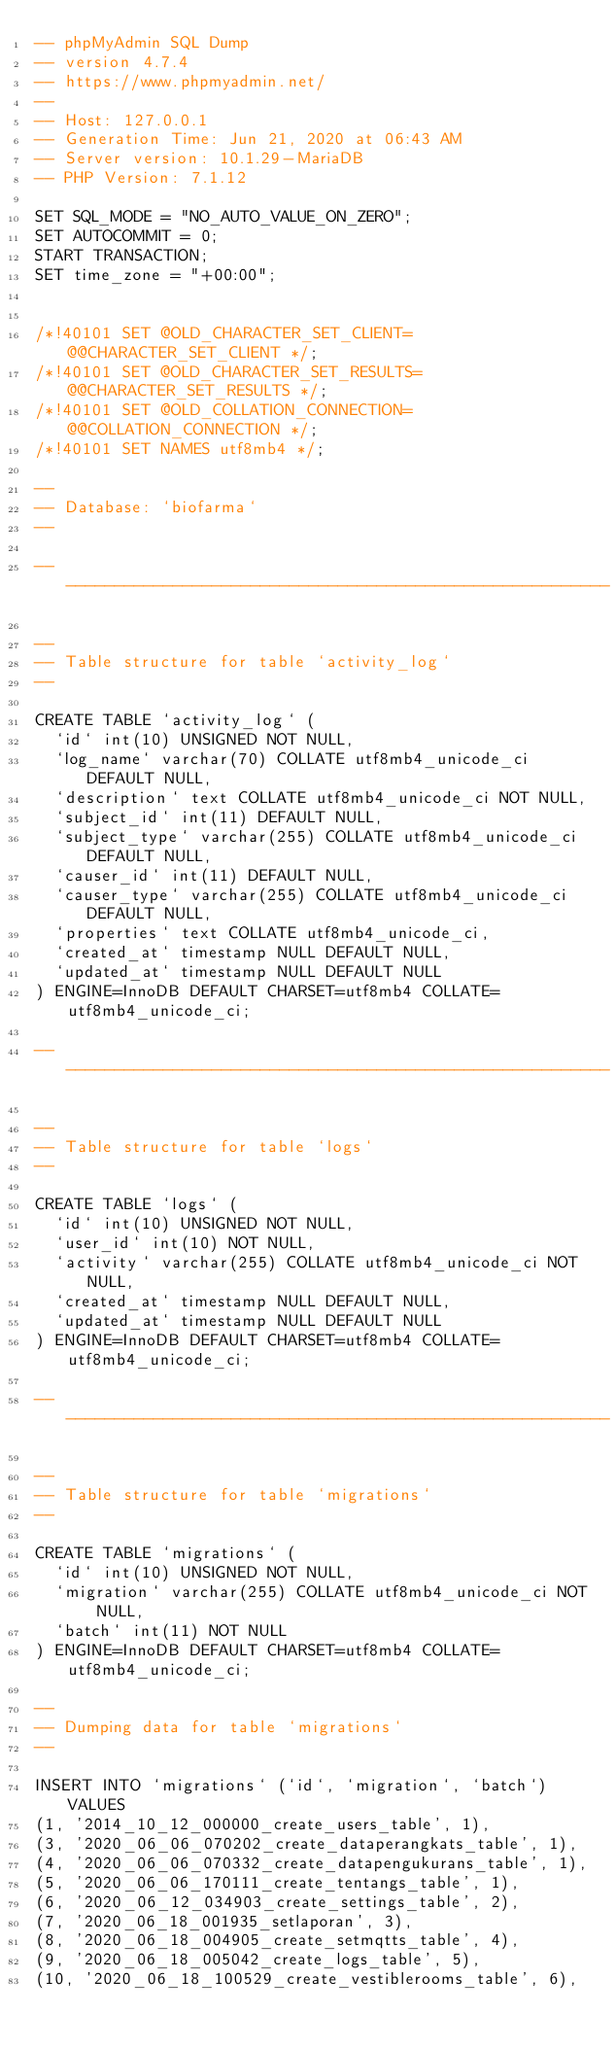<code> <loc_0><loc_0><loc_500><loc_500><_SQL_>-- phpMyAdmin SQL Dump
-- version 4.7.4
-- https://www.phpmyadmin.net/
--
-- Host: 127.0.0.1
-- Generation Time: Jun 21, 2020 at 06:43 AM
-- Server version: 10.1.29-MariaDB
-- PHP Version: 7.1.12

SET SQL_MODE = "NO_AUTO_VALUE_ON_ZERO";
SET AUTOCOMMIT = 0;
START TRANSACTION;
SET time_zone = "+00:00";


/*!40101 SET @OLD_CHARACTER_SET_CLIENT=@@CHARACTER_SET_CLIENT */;
/*!40101 SET @OLD_CHARACTER_SET_RESULTS=@@CHARACTER_SET_RESULTS */;
/*!40101 SET @OLD_COLLATION_CONNECTION=@@COLLATION_CONNECTION */;
/*!40101 SET NAMES utf8mb4 */;

--
-- Database: `biofarma`
--

-- --------------------------------------------------------

--
-- Table structure for table `activity_log`
--

CREATE TABLE `activity_log` (
  `id` int(10) UNSIGNED NOT NULL,
  `log_name` varchar(70) COLLATE utf8mb4_unicode_ci DEFAULT NULL,
  `description` text COLLATE utf8mb4_unicode_ci NOT NULL,
  `subject_id` int(11) DEFAULT NULL,
  `subject_type` varchar(255) COLLATE utf8mb4_unicode_ci DEFAULT NULL,
  `causer_id` int(11) DEFAULT NULL,
  `causer_type` varchar(255) COLLATE utf8mb4_unicode_ci DEFAULT NULL,
  `properties` text COLLATE utf8mb4_unicode_ci,
  `created_at` timestamp NULL DEFAULT NULL,
  `updated_at` timestamp NULL DEFAULT NULL
) ENGINE=InnoDB DEFAULT CHARSET=utf8mb4 COLLATE=utf8mb4_unicode_ci;

-- --------------------------------------------------------

--
-- Table structure for table `logs`
--

CREATE TABLE `logs` (
  `id` int(10) UNSIGNED NOT NULL,
  `user_id` int(10) NOT NULL,
  `activity` varchar(255) COLLATE utf8mb4_unicode_ci NOT NULL,
  `created_at` timestamp NULL DEFAULT NULL,
  `updated_at` timestamp NULL DEFAULT NULL
) ENGINE=InnoDB DEFAULT CHARSET=utf8mb4 COLLATE=utf8mb4_unicode_ci;

-- --------------------------------------------------------

--
-- Table structure for table `migrations`
--

CREATE TABLE `migrations` (
  `id` int(10) UNSIGNED NOT NULL,
  `migration` varchar(255) COLLATE utf8mb4_unicode_ci NOT NULL,
  `batch` int(11) NOT NULL
) ENGINE=InnoDB DEFAULT CHARSET=utf8mb4 COLLATE=utf8mb4_unicode_ci;

--
-- Dumping data for table `migrations`
--

INSERT INTO `migrations` (`id`, `migration`, `batch`) VALUES
(1, '2014_10_12_000000_create_users_table', 1),
(3, '2020_06_06_070202_create_dataperangkats_table', 1),
(4, '2020_06_06_070332_create_datapengukurans_table', 1),
(5, '2020_06_06_170111_create_tentangs_table', 1),
(6, '2020_06_12_034903_create_settings_table', 2),
(7, '2020_06_18_001935_setlaporan', 3),
(8, '2020_06_18_004905_create_setmqtts_table', 4),
(9, '2020_06_18_005042_create_logs_table', 5),
(10, '2020_06_18_100529_create_vestiblerooms_table', 6),</code> 